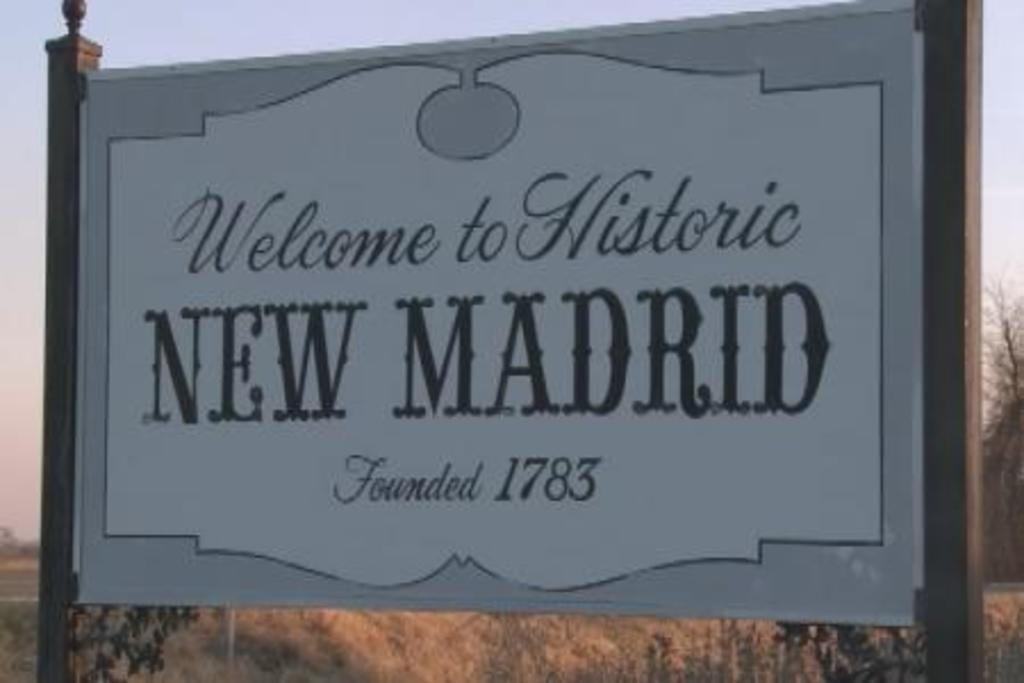<image>
Present a compact description of the photo's key features. An outdoor placard that reads Welcome to Historic New Madrid. 